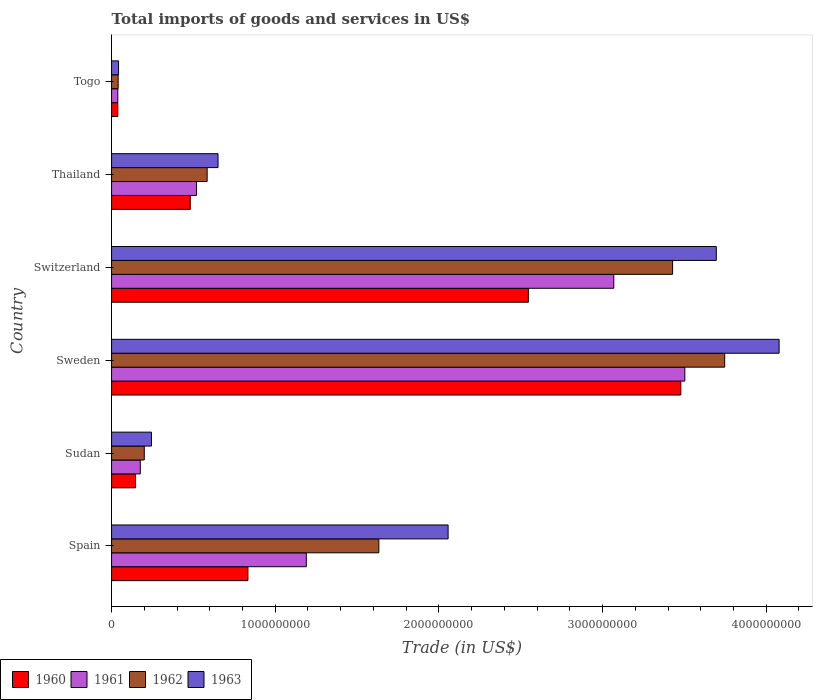How many groups of bars are there?
Your response must be concise. 6. Are the number of bars per tick equal to the number of legend labels?
Offer a terse response. Yes. Are the number of bars on each tick of the Y-axis equal?
Make the answer very short. Yes. What is the label of the 6th group of bars from the top?
Provide a short and direct response. Spain. What is the total imports of goods and services in 1961 in Switzerland?
Offer a terse response. 3.07e+09. Across all countries, what is the maximum total imports of goods and services in 1961?
Your response must be concise. 3.50e+09. Across all countries, what is the minimum total imports of goods and services in 1960?
Your answer should be compact. 3.82e+07. In which country was the total imports of goods and services in 1962 minimum?
Offer a very short reply. Togo. What is the total total imports of goods and services in 1961 in the graph?
Provide a succinct answer. 8.49e+09. What is the difference between the total imports of goods and services in 1963 in Sudan and that in Switzerland?
Provide a succinct answer. -3.45e+09. What is the difference between the total imports of goods and services in 1963 in Sudan and the total imports of goods and services in 1961 in Sweden?
Offer a terse response. -3.26e+09. What is the average total imports of goods and services in 1961 per country?
Offer a very short reply. 1.42e+09. What is the difference between the total imports of goods and services in 1960 and total imports of goods and services in 1962 in Thailand?
Ensure brevity in your answer.  -1.03e+08. What is the ratio of the total imports of goods and services in 1961 in Spain to that in Togo?
Keep it short and to the point. 31.15. Is the total imports of goods and services in 1962 in Sweden less than that in Thailand?
Ensure brevity in your answer.  No. Is the difference between the total imports of goods and services in 1960 in Thailand and Togo greater than the difference between the total imports of goods and services in 1962 in Thailand and Togo?
Keep it short and to the point. No. What is the difference between the highest and the second highest total imports of goods and services in 1963?
Your answer should be very brief. 3.84e+08. What is the difference between the highest and the lowest total imports of goods and services in 1960?
Make the answer very short. 3.44e+09. In how many countries, is the total imports of goods and services in 1963 greater than the average total imports of goods and services in 1963 taken over all countries?
Your response must be concise. 3. Is it the case that in every country, the sum of the total imports of goods and services in 1963 and total imports of goods and services in 1961 is greater than the sum of total imports of goods and services in 1960 and total imports of goods and services in 1962?
Give a very brief answer. No. What does the 3rd bar from the top in Togo represents?
Provide a succinct answer. 1961. What does the 2nd bar from the bottom in Sudan represents?
Provide a succinct answer. 1961. Is it the case that in every country, the sum of the total imports of goods and services in 1963 and total imports of goods and services in 1961 is greater than the total imports of goods and services in 1962?
Ensure brevity in your answer.  Yes. How many bars are there?
Offer a terse response. 24. What is the difference between two consecutive major ticks on the X-axis?
Provide a short and direct response. 1.00e+09. Does the graph contain any zero values?
Keep it short and to the point. No. Where does the legend appear in the graph?
Provide a succinct answer. Bottom left. How many legend labels are there?
Your answer should be compact. 4. How are the legend labels stacked?
Offer a terse response. Horizontal. What is the title of the graph?
Your response must be concise. Total imports of goods and services in US$. Does "2003" appear as one of the legend labels in the graph?
Provide a succinct answer. No. What is the label or title of the X-axis?
Offer a terse response. Trade (in US$). What is the label or title of the Y-axis?
Provide a succinct answer. Country. What is the Trade (in US$) of 1960 in Spain?
Provide a short and direct response. 8.33e+08. What is the Trade (in US$) in 1961 in Spain?
Your response must be concise. 1.19e+09. What is the Trade (in US$) of 1962 in Spain?
Offer a very short reply. 1.63e+09. What is the Trade (in US$) in 1963 in Spain?
Provide a short and direct response. 2.06e+09. What is the Trade (in US$) in 1960 in Sudan?
Give a very brief answer. 1.46e+08. What is the Trade (in US$) in 1961 in Sudan?
Your response must be concise. 1.75e+08. What is the Trade (in US$) of 1962 in Sudan?
Provide a succinct answer. 2.00e+08. What is the Trade (in US$) in 1963 in Sudan?
Offer a very short reply. 2.44e+08. What is the Trade (in US$) in 1960 in Sweden?
Ensure brevity in your answer.  3.48e+09. What is the Trade (in US$) in 1961 in Sweden?
Provide a short and direct response. 3.50e+09. What is the Trade (in US$) of 1962 in Sweden?
Provide a short and direct response. 3.75e+09. What is the Trade (in US$) in 1963 in Sweden?
Make the answer very short. 4.08e+09. What is the Trade (in US$) of 1960 in Switzerland?
Offer a very short reply. 2.55e+09. What is the Trade (in US$) in 1961 in Switzerland?
Provide a succinct answer. 3.07e+09. What is the Trade (in US$) in 1962 in Switzerland?
Give a very brief answer. 3.43e+09. What is the Trade (in US$) of 1963 in Switzerland?
Offer a terse response. 3.69e+09. What is the Trade (in US$) in 1960 in Thailand?
Make the answer very short. 4.81e+08. What is the Trade (in US$) in 1961 in Thailand?
Provide a short and direct response. 5.19e+08. What is the Trade (in US$) of 1962 in Thailand?
Ensure brevity in your answer.  5.84e+08. What is the Trade (in US$) of 1963 in Thailand?
Offer a very short reply. 6.51e+08. What is the Trade (in US$) of 1960 in Togo?
Give a very brief answer. 3.82e+07. What is the Trade (in US$) of 1961 in Togo?
Provide a short and direct response. 3.82e+07. What is the Trade (in US$) in 1962 in Togo?
Provide a succinct answer. 4.02e+07. What is the Trade (in US$) in 1963 in Togo?
Your answer should be very brief. 4.27e+07. Across all countries, what is the maximum Trade (in US$) of 1960?
Offer a terse response. 3.48e+09. Across all countries, what is the maximum Trade (in US$) of 1961?
Provide a short and direct response. 3.50e+09. Across all countries, what is the maximum Trade (in US$) of 1962?
Keep it short and to the point. 3.75e+09. Across all countries, what is the maximum Trade (in US$) in 1963?
Offer a terse response. 4.08e+09. Across all countries, what is the minimum Trade (in US$) in 1960?
Keep it short and to the point. 3.82e+07. Across all countries, what is the minimum Trade (in US$) in 1961?
Make the answer very short. 3.82e+07. Across all countries, what is the minimum Trade (in US$) of 1962?
Give a very brief answer. 4.02e+07. Across all countries, what is the minimum Trade (in US$) of 1963?
Offer a very short reply. 4.27e+07. What is the total Trade (in US$) in 1960 in the graph?
Give a very brief answer. 7.52e+09. What is the total Trade (in US$) of 1961 in the graph?
Give a very brief answer. 8.49e+09. What is the total Trade (in US$) in 1962 in the graph?
Offer a very short reply. 9.63e+09. What is the total Trade (in US$) in 1963 in the graph?
Provide a short and direct response. 1.08e+1. What is the difference between the Trade (in US$) in 1960 in Spain and that in Sudan?
Ensure brevity in your answer.  6.87e+08. What is the difference between the Trade (in US$) of 1961 in Spain and that in Sudan?
Your response must be concise. 1.01e+09. What is the difference between the Trade (in US$) in 1962 in Spain and that in Sudan?
Give a very brief answer. 1.43e+09. What is the difference between the Trade (in US$) in 1963 in Spain and that in Sudan?
Offer a very short reply. 1.81e+09. What is the difference between the Trade (in US$) of 1960 in Spain and that in Sweden?
Provide a succinct answer. -2.65e+09. What is the difference between the Trade (in US$) of 1961 in Spain and that in Sweden?
Your answer should be very brief. -2.31e+09. What is the difference between the Trade (in US$) in 1962 in Spain and that in Sweden?
Your response must be concise. -2.11e+09. What is the difference between the Trade (in US$) of 1963 in Spain and that in Sweden?
Offer a terse response. -2.02e+09. What is the difference between the Trade (in US$) of 1960 in Spain and that in Switzerland?
Keep it short and to the point. -1.71e+09. What is the difference between the Trade (in US$) of 1961 in Spain and that in Switzerland?
Your response must be concise. -1.88e+09. What is the difference between the Trade (in US$) of 1962 in Spain and that in Switzerland?
Your answer should be very brief. -1.79e+09. What is the difference between the Trade (in US$) in 1963 in Spain and that in Switzerland?
Keep it short and to the point. -1.64e+09. What is the difference between the Trade (in US$) of 1960 in Spain and that in Thailand?
Offer a very short reply. 3.52e+08. What is the difference between the Trade (in US$) of 1961 in Spain and that in Thailand?
Ensure brevity in your answer.  6.71e+08. What is the difference between the Trade (in US$) of 1962 in Spain and that in Thailand?
Keep it short and to the point. 1.05e+09. What is the difference between the Trade (in US$) of 1963 in Spain and that in Thailand?
Provide a succinct answer. 1.41e+09. What is the difference between the Trade (in US$) of 1960 in Spain and that in Togo?
Your response must be concise. 7.95e+08. What is the difference between the Trade (in US$) of 1961 in Spain and that in Togo?
Offer a very short reply. 1.15e+09. What is the difference between the Trade (in US$) of 1962 in Spain and that in Togo?
Offer a very short reply. 1.59e+09. What is the difference between the Trade (in US$) in 1963 in Spain and that in Togo?
Keep it short and to the point. 2.01e+09. What is the difference between the Trade (in US$) in 1960 in Sudan and that in Sweden?
Keep it short and to the point. -3.33e+09. What is the difference between the Trade (in US$) in 1961 in Sudan and that in Sweden?
Ensure brevity in your answer.  -3.33e+09. What is the difference between the Trade (in US$) in 1962 in Sudan and that in Sweden?
Offer a very short reply. -3.55e+09. What is the difference between the Trade (in US$) in 1963 in Sudan and that in Sweden?
Your answer should be very brief. -3.83e+09. What is the difference between the Trade (in US$) in 1960 in Sudan and that in Switzerland?
Your answer should be very brief. -2.40e+09. What is the difference between the Trade (in US$) of 1961 in Sudan and that in Switzerland?
Ensure brevity in your answer.  -2.89e+09. What is the difference between the Trade (in US$) in 1962 in Sudan and that in Switzerland?
Provide a short and direct response. -3.23e+09. What is the difference between the Trade (in US$) of 1963 in Sudan and that in Switzerland?
Your answer should be very brief. -3.45e+09. What is the difference between the Trade (in US$) of 1960 in Sudan and that in Thailand?
Ensure brevity in your answer.  -3.34e+08. What is the difference between the Trade (in US$) in 1961 in Sudan and that in Thailand?
Provide a short and direct response. -3.44e+08. What is the difference between the Trade (in US$) in 1962 in Sudan and that in Thailand?
Make the answer very short. -3.84e+08. What is the difference between the Trade (in US$) in 1963 in Sudan and that in Thailand?
Ensure brevity in your answer.  -4.07e+08. What is the difference between the Trade (in US$) of 1960 in Sudan and that in Togo?
Provide a short and direct response. 1.08e+08. What is the difference between the Trade (in US$) of 1961 in Sudan and that in Togo?
Provide a succinct answer. 1.37e+08. What is the difference between the Trade (in US$) in 1962 in Sudan and that in Togo?
Keep it short and to the point. 1.60e+08. What is the difference between the Trade (in US$) of 1963 in Sudan and that in Togo?
Your answer should be very brief. 2.01e+08. What is the difference between the Trade (in US$) in 1960 in Sweden and that in Switzerland?
Provide a succinct answer. 9.31e+08. What is the difference between the Trade (in US$) in 1961 in Sweden and that in Switzerland?
Your answer should be compact. 4.34e+08. What is the difference between the Trade (in US$) in 1962 in Sweden and that in Switzerland?
Your response must be concise. 3.18e+08. What is the difference between the Trade (in US$) of 1963 in Sweden and that in Switzerland?
Your answer should be compact. 3.84e+08. What is the difference between the Trade (in US$) in 1960 in Sweden and that in Thailand?
Give a very brief answer. 3.00e+09. What is the difference between the Trade (in US$) of 1961 in Sweden and that in Thailand?
Offer a very short reply. 2.98e+09. What is the difference between the Trade (in US$) of 1962 in Sweden and that in Thailand?
Your answer should be very brief. 3.16e+09. What is the difference between the Trade (in US$) of 1963 in Sweden and that in Thailand?
Give a very brief answer. 3.43e+09. What is the difference between the Trade (in US$) of 1960 in Sweden and that in Togo?
Make the answer very short. 3.44e+09. What is the difference between the Trade (in US$) in 1961 in Sweden and that in Togo?
Offer a terse response. 3.46e+09. What is the difference between the Trade (in US$) of 1962 in Sweden and that in Togo?
Your response must be concise. 3.71e+09. What is the difference between the Trade (in US$) of 1963 in Sweden and that in Togo?
Offer a very short reply. 4.04e+09. What is the difference between the Trade (in US$) of 1960 in Switzerland and that in Thailand?
Provide a short and direct response. 2.07e+09. What is the difference between the Trade (in US$) in 1961 in Switzerland and that in Thailand?
Offer a terse response. 2.55e+09. What is the difference between the Trade (in US$) in 1962 in Switzerland and that in Thailand?
Offer a very short reply. 2.84e+09. What is the difference between the Trade (in US$) in 1963 in Switzerland and that in Thailand?
Keep it short and to the point. 3.04e+09. What is the difference between the Trade (in US$) in 1960 in Switzerland and that in Togo?
Your answer should be compact. 2.51e+09. What is the difference between the Trade (in US$) in 1961 in Switzerland and that in Togo?
Make the answer very short. 3.03e+09. What is the difference between the Trade (in US$) of 1962 in Switzerland and that in Togo?
Make the answer very short. 3.39e+09. What is the difference between the Trade (in US$) of 1963 in Switzerland and that in Togo?
Your response must be concise. 3.65e+09. What is the difference between the Trade (in US$) in 1960 in Thailand and that in Togo?
Make the answer very short. 4.43e+08. What is the difference between the Trade (in US$) in 1961 in Thailand and that in Togo?
Offer a very short reply. 4.81e+08. What is the difference between the Trade (in US$) of 1962 in Thailand and that in Togo?
Your answer should be compact. 5.44e+08. What is the difference between the Trade (in US$) in 1963 in Thailand and that in Togo?
Ensure brevity in your answer.  6.08e+08. What is the difference between the Trade (in US$) of 1960 in Spain and the Trade (in US$) of 1961 in Sudan?
Offer a very short reply. 6.58e+08. What is the difference between the Trade (in US$) in 1960 in Spain and the Trade (in US$) in 1962 in Sudan?
Your response must be concise. 6.33e+08. What is the difference between the Trade (in US$) in 1960 in Spain and the Trade (in US$) in 1963 in Sudan?
Give a very brief answer. 5.89e+08. What is the difference between the Trade (in US$) of 1961 in Spain and the Trade (in US$) of 1962 in Sudan?
Offer a terse response. 9.90e+08. What is the difference between the Trade (in US$) of 1961 in Spain and the Trade (in US$) of 1963 in Sudan?
Your answer should be very brief. 9.46e+08. What is the difference between the Trade (in US$) of 1962 in Spain and the Trade (in US$) of 1963 in Sudan?
Your response must be concise. 1.39e+09. What is the difference between the Trade (in US$) of 1960 in Spain and the Trade (in US$) of 1961 in Sweden?
Keep it short and to the point. -2.67e+09. What is the difference between the Trade (in US$) in 1960 in Spain and the Trade (in US$) in 1962 in Sweden?
Provide a short and direct response. -2.91e+09. What is the difference between the Trade (in US$) in 1960 in Spain and the Trade (in US$) in 1963 in Sweden?
Offer a terse response. -3.25e+09. What is the difference between the Trade (in US$) in 1961 in Spain and the Trade (in US$) in 1962 in Sweden?
Ensure brevity in your answer.  -2.56e+09. What is the difference between the Trade (in US$) of 1961 in Spain and the Trade (in US$) of 1963 in Sweden?
Ensure brevity in your answer.  -2.89e+09. What is the difference between the Trade (in US$) in 1962 in Spain and the Trade (in US$) in 1963 in Sweden?
Your answer should be very brief. -2.45e+09. What is the difference between the Trade (in US$) of 1960 in Spain and the Trade (in US$) of 1961 in Switzerland?
Your response must be concise. -2.24e+09. What is the difference between the Trade (in US$) of 1960 in Spain and the Trade (in US$) of 1962 in Switzerland?
Your answer should be compact. -2.59e+09. What is the difference between the Trade (in US$) of 1960 in Spain and the Trade (in US$) of 1963 in Switzerland?
Your response must be concise. -2.86e+09. What is the difference between the Trade (in US$) of 1961 in Spain and the Trade (in US$) of 1962 in Switzerland?
Make the answer very short. -2.24e+09. What is the difference between the Trade (in US$) of 1961 in Spain and the Trade (in US$) of 1963 in Switzerland?
Keep it short and to the point. -2.50e+09. What is the difference between the Trade (in US$) in 1962 in Spain and the Trade (in US$) in 1963 in Switzerland?
Offer a very short reply. -2.06e+09. What is the difference between the Trade (in US$) of 1960 in Spain and the Trade (in US$) of 1961 in Thailand?
Your answer should be compact. 3.14e+08. What is the difference between the Trade (in US$) of 1960 in Spain and the Trade (in US$) of 1962 in Thailand?
Your answer should be very brief. 2.49e+08. What is the difference between the Trade (in US$) in 1960 in Spain and the Trade (in US$) in 1963 in Thailand?
Ensure brevity in your answer.  1.83e+08. What is the difference between the Trade (in US$) of 1961 in Spain and the Trade (in US$) of 1962 in Thailand?
Your response must be concise. 6.06e+08. What is the difference between the Trade (in US$) in 1961 in Spain and the Trade (in US$) in 1963 in Thailand?
Offer a terse response. 5.39e+08. What is the difference between the Trade (in US$) in 1962 in Spain and the Trade (in US$) in 1963 in Thailand?
Provide a succinct answer. 9.83e+08. What is the difference between the Trade (in US$) of 1960 in Spain and the Trade (in US$) of 1961 in Togo?
Provide a succinct answer. 7.95e+08. What is the difference between the Trade (in US$) in 1960 in Spain and the Trade (in US$) in 1962 in Togo?
Your answer should be very brief. 7.93e+08. What is the difference between the Trade (in US$) of 1960 in Spain and the Trade (in US$) of 1963 in Togo?
Your response must be concise. 7.90e+08. What is the difference between the Trade (in US$) of 1961 in Spain and the Trade (in US$) of 1962 in Togo?
Ensure brevity in your answer.  1.15e+09. What is the difference between the Trade (in US$) in 1961 in Spain and the Trade (in US$) in 1963 in Togo?
Provide a short and direct response. 1.15e+09. What is the difference between the Trade (in US$) in 1962 in Spain and the Trade (in US$) in 1963 in Togo?
Provide a succinct answer. 1.59e+09. What is the difference between the Trade (in US$) of 1960 in Sudan and the Trade (in US$) of 1961 in Sweden?
Your answer should be compact. -3.36e+09. What is the difference between the Trade (in US$) in 1960 in Sudan and the Trade (in US$) in 1962 in Sweden?
Ensure brevity in your answer.  -3.60e+09. What is the difference between the Trade (in US$) in 1960 in Sudan and the Trade (in US$) in 1963 in Sweden?
Keep it short and to the point. -3.93e+09. What is the difference between the Trade (in US$) of 1961 in Sudan and the Trade (in US$) of 1962 in Sweden?
Keep it short and to the point. -3.57e+09. What is the difference between the Trade (in US$) of 1961 in Sudan and the Trade (in US$) of 1963 in Sweden?
Offer a terse response. -3.90e+09. What is the difference between the Trade (in US$) in 1962 in Sudan and the Trade (in US$) in 1963 in Sweden?
Make the answer very short. -3.88e+09. What is the difference between the Trade (in US$) of 1960 in Sudan and the Trade (in US$) of 1961 in Switzerland?
Make the answer very short. -2.92e+09. What is the difference between the Trade (in US$) of 1960 in Sudan and the Trade (in US$) of 1962 in Switzerland?
Ensure brevity in your answer.  -3.28e+09. What is the difference between the Trade (in US$) of 1960 in Sudan and the Trade (in US$) of 1963 in Switzerland?
Your response must be concise. -3.55e+09. What is the difference between the Trade (in US$) in 1961 in Sudan and the Trade (in US$) in 1962 in Switzerland?
Provide a succinct answer. -3.25e+09. What is the difference between the Trade (in US$) in 1961 in Sudan and the Trade (in US$) in 1963 in Switzerland?
Ensure brevity in your answer.  -3.52e+09. What is the difference between the Trade (in US$) of 1962 in Sudan and the Trade (in US$) of 1963 in Switzerland?
Provide a short and direct response. -3.49e+09. What is the difference between the Trade (in US$) in 1960 in Sudan and the Trade (in US$) in 1961 in Thailand?
Your response must be concise. -3.73e+08. What is the difference between the Trade (in US$) in 1960 in Sudan and the Trade (in US$) in 1962 in Thailand?
Offer a terse response. -4.38e+08. What is the difference between the Trade (in US$) of 1960 in Sudan and the Trade (in US$) of 1963 in Thailand?
Make the answer very short. -5.04e+08. What is the difference between the Trade (in US$) of 1961 in Sudan and the Trade (in US$) of 1962 in Thailand?
Offer a terse response. -4.09e+08. What is the difference between the Trade (in US$) of 1961 in Sudan and the Trade (in US$) of 1963 in Thailand?
Make the answer very short. -4.75e+08. What is the difference between the Trade (in US$) of 1962 in Sudan and the Trade (in US$) of 1963 in Thailand?
Provide a short and direct response. -4.51e+08. What is the difference between the Trade (in US$) in 1960 in Sudan and the Trade (in US$) in 1961 in Togo?
Your answer should be very brief. 1.08e+08. What is the difference between the Trade (in US$) of 1960 in Sudan and the Trade (in US$) of 1962 in Togo?
Offer a terse response. 1.06e+08. What is the difference between the Trade (in US$) of 1960 in Sudan and the Trade (in US$) of 1963 in Togo?
Your response must be concise. 1.04e+08. What is the difference between the Trade (in US$) in 1961 in Sudan and the Trade (in US$) in 1962 in Togo?
Your answer should be compact. 1.35e+08. What is the difference between the Trade (in US$) in 1961 in Sudan and the Trade (in US$) in 1963 in Togo?
Provide a succinct answer. 1.33e+08. What is the difference between the Trade (in US$) in 1962 in Sudan and the Trade (in US$) in 1963 in Togo?
Offer a very short reply. 1.57e+08. What is the difference between the Trade (in US$) of 1960 in Sweden and the Trade (in US$) of 1961 in Switzerland?
Make the answer very short. 4.10e+08. What is the difference between the Trade (in US$) in 1960 in Sweden and the Trade (in US$) in 1962 in Switzerland?
Offer a very short reply. 5.05e+07. What is the difference between the Trade (in US$) in 1960 in Sweden and the Trade (in US$) in 1963 in Switzerland?
Your answer should be compact. -2.17e+08. What is the difference between the Trade (in US$) of 1961 in Sweden and the Trade (in US$) of 1962 in Switzerland?
Provide a short and direct response. 7.48e+07. What is the difference between the Trade (in US$) of 1961 in Sweden and the Trade (in US$) of 1963 in Switzerland?
Give a very brief answer. -1.92e+08. What is the difference between the Trade (in US$) of 1962 in Sweden and the Trade (in US$) of 1963 in Switzerland?
Ensure brevity in your answer.  5.13e+07. What is the difference between the Trade (in US$) in 1960 in Sweden and the Trade (in US$) in 1961 in Thailand?
Offer a terse response. 2.96e+09. What is the difference between the Trade (in US$) of 1960 in Sweden and the Trade (in US$) of 1962 in Thailand?
Keep it short and to the point. 2.89e+09. What is the difference between the Trade (in US$) of 1960 in Sweden and the Trade (in US$) of 1963 in Thailand?
Make the answer very short. 2.83e+09. What is the difference between the Trade (in US$) in 1961 in Sweden and the Trade (in US$) in 1962 in Thailand?
Provide a succinct answer. 2.92e+09. What is the difference between the Trade (in US$) of 1961 in Sweden and the Trade (in US$) of 1963 in Thailand?
Offer a very short reply. 2.85e+09. What is the difference between the Trade (in US$) in 1962 in Sweden and the Trade (in US$) in 1963 in Thailand?
Your answer should be compact. 3.10e+09. What is the difference between the Trade (in US$) of 1960 in Sweden and the Trade (in US$) of 1961 in Togo?
Make the answer very short. 3.44e+09. What is the difference between the Trade (in US$) in 1960 in Sweden and the Trade (in US$) in 1962 in Togo?
Provide a short and direct response. 3.44e+09. What is the difference between the Trade (in US$) of 1960 in Sweden and the Trade (in US$) of 1963 in Togo?
Offer a terse response. 3.44e+09. What is the difference between the Trade (in US$) of 1961 in Sweden and the Trade (in US$) of 1962 in Togo?
Keep it short and to the point. 3.46e+09. What is the difference between the Trade (in US$) of 1961 in Sweden and the Trade (in US$) of 1963 in Togo?
Provide a short and direct response. 3.46e+09. What is the difference between the Trade (in US$) of 1962 in Sweden and the Trade (in US$) of 1963 in Togo?
Give a very brief answer. 3.70e+09. What is the difference between the Trade (in US$) of 1960 in Switzerland and the Trade (in US$) of 1961 in Thailand?
Ensure brevity in your answer.  2.03e+09. What is the difference between the Trade (in US$) in 1960 in Switzerland and the Trade (in US$) in 1962 in Thailand?
Provide a short and direct response. 1.96e+09. What is the difference between the Trade (in US$) of 1960 in Switzerland and the Trade (in US$) of 1963 in Thailand?
Your response must be concise. 1.90e+09. What is the difference between the Trade (in US$) in 1961 in Switzerland and the Trade (in US$) in 1962 in Thailand?
Offer a very short reply. 2.48e+09. What is the difference between the Trade (in US$) of 1961 in Switzerland and the Trade (in US$) of 1963 in Thailand?
Keep it short and to the point. 2.42e+09. What is the difference between the Trade (in US$) in 1962 in Switzerland and the Trade (in US$) in 1963 in Thailand?
Offer a very short reply. 2.78e+09. What is the difference between the Trade (in US$) in 1960 in Switzerland and the Trade (in US$) in 1961 in Togo?
Make the answer very short. 2.51e+09. What is the difference between the Trade (in US$) in 1960 in Switzerland and the Trade (in US$) in 1962 in Togo?
Provide a succinct answer. 2.51e+09. What is the difference between the Trade (in US$) in 1960 in Switzerland and the Trade (in US$) in 1963 in Togo?
Your answer should be very brief. 2.50e+09. What is the difference between the Trade (in US$) of 1961 in Switzerland and the Trade (in US$) of 1962 in Togo?
Your answer should be very brief. 3.03e+09. What is the difference between the Trade (in US$) of 1961 in Switzerland and the Trade (in US$) of 1963 in Togo?
Provide a succinct answer. 3.03e+09. What is the difference between the Trade (in US$) in 1962 in Switzerland and the Trade (in US$) in 1963 in Togo?
Give a very brief answer. 3.38e+09. What is the difference between the Trade (in US$) of 1960 in Thailand and the Trade (in US$) of 1961 in Togo?
Your answer should be compact. 4.43e+08. What is the difference between the Trade (in US$) in 1960 in Thailand and the Trade (in US$) in 1962 in Togo?
Your response must be concise. 4.41e+08. What is the difference between the Trade (in US$) of 1960 in Thailand and the Trade (in US$) of 1963 in Togo?
Your answer should be very brief. 4.38e+08. What is the difference between the Trade (in US$) of 1961 in Thailand and the Trade (in US$) of 1962 in Togo?
Keep it short and to the point. 4.79e+08. What is the difference between the Trade (in US$) of 1961 in Thailand and the Trade (in US$) of 1963 in Togo?
Make the answer very short. 4.76e+08. What is the difference between the Trade (in US$) in 1962 in Thailand and the Trade (in US$) in 1963 in Togo?
Your answer should be compact. 5.41e+08. What is the average Trade (in US$) in 1960 per country?
Make the answer very short. 1.25e+09. What is the average Trade (in US$) of 1961 per country?
Make the answer very short. 1.42e+09. What is the average Trade (in US$) of 1962 per country?
Ensure brevity in your answer.  1.61e+09. What is the average Trade (in US$) in 1963 per country?
Make the answer very short. 1.79e+09. What is the difference between the Trade (in US$) of 1960 and Trade (in US$) of 1961 in Spain?
Ensure brevity in your answer.  -3.57e+08. What is the difference between the Trade (in US$) in 1960 and Trade (in US$) in 1962 in Spain?
Your answer should be compact. -8.00e+08. What is the difference between the Trade (in US$) of 1960 and Trade (in US$) of 1963 in Spain?
Offer a very short reply. -1.22e+09. What is the difference between the Trade (in US$) of 1961 and Trade (in US$) of 1962 in Spain?
Make the answer very short. -4.43e+08. What is the difference between the Trade (in US$) of 1961 and Trade (in US$) of 1963 in Spain?
Offer a terse response. -8.66e+08. What is the difference between the Trade (in US$) in 1962 and Trade (in US$) in 1963 in Spain?
Keep it short and to the point. -4.23e+08. What is the difference between the Trade (in US$) in 1960 and Trade (in US$) in 1961 in Sudan?
Give a very brief answer. -2.90e+07. What is the difference between the Trade (in US$) of 1960 and Trade (in US$) of 1962 in Sudan?
Your answer should be very brief. -5.34e+07. What is the difference between the Trade (in US$) of 1960 and Trade (in US$) of 1963 in Sudan?
Offer a terse response. -9.74e+07. What is the difference between the Trade (in US$) in 1961 and Trade (in US$) in 1962 in Sudan?
Give a very brief answer. -2.44e+07. What is the difference between the Trade (in US$) of 1961 and Trade (in US$) of 1963 in Sudan?
Give a very brief answer. -6.84e+07. What is the difference between the Trade (in US$) of 1962 and Trade (in US$) of 1963 in Sudan?
Offer a terse response. -4.39e+07. What is the difference between the Trade (in US$) of 1960 and Trade (in US$) of 1961 in Sweden?
Your answer should be compact. -2.44e+07. What is the difference between the Trade (in US$) of 1960 and Trade (in US$) of 1962 in Sweden?
Offer a very short reply. -2.68e+08. What is the difference between the Trade (in US$) in 1960 and Trade (in US$) in 1963 in Sweden?
Your response must be concise. -6.00e+08. What is the difference between the Trade (in US$) in 1961 and Trade (in US$) in 1962 in Sweden?
Offer a terse response. -2.44e+08. What is the difference between the Trade (in US$) of 1961 and Trade (in US$) of 1963 in Sweden?
Offer a very short reply. -5.76e+08. What is the difference between the Trade (in US$) in 1962 and Trade (in US$) in 1963 in Sweden?
Offer a terse response. -3.33e+08. What is the difference between the Trade (in US$) in 1960 and Trade (in US$) in 1961 in Switzerland?
Your answer should be very brief. -5.22e+08. What is the difference between the Trade (in US$) of 1960 and Trade (in US$) of 1962 in Switzerland?
Your response must be concise. -8.81e+08. What is the difference between the Trade (in US$) in 1960 and Trade (in US$) in 1963 in Switzerland?
Your answer should be very brief. -1.15e+09. What is the difference between the Trade (in US$) of 1961 and Trade (in US$) of 1962 in Switzerland?
Keep it short and to the point. -3.59e+08. What is the difference between the Trade (in US$) in 1961 and Trade (in US$) in 1963 in Switzerland?
Offer a terse response. -6.26e+08. What is the difference between the Trade (in US$) of 1962 and Trade (in US$) of 1963 in Switzerland?
Keep it short and to the point. -2.67e+08. What is the difference between the Trade (in US$) in 1960 and Trade (in US$) in 1961 in Thailand?
Provide a short and direct response. -3.83e+07. What is the difference between the Trade (in US$) of 1960 and Trade (in US$) of 1962 in Thailand?
Keep it short and to the point. -1.03e+08. What is the difference between the Trade (in US$) of 1960 and Trade (in US$) of 1963 in Thailand?
Your response must be concise. -1.70e+08. What is the difference between the Trade (in US$) in 1961 and Trade (in US$) in 1962 in Thailand?
Give a very brief answer. -6.49e+07. What is the difference between the Trade (in US$) of 1961 and Trade (in US$) of 1963 in Thailand?
Make the answer very short. -1.31e+08. What is the difference between the Trade (in US$) of 1962 and Trade (in US$) of 1963 in Thailand?
Make the answer very short. -6.65e+07. What is the difference between the Trade (in US$) of 1960 and Trade (in US$) of 1961 in Togo?
Your answer should be very brief. 1.01e+04. What is the difference between the Trade (in US$) in 1960 and Trade (in US$) in 1962 in Togo?
Give a very brief answer. -2.01e+06. What is the difference between the Trade (in US$) in 1960 and Trade (in US$) in 1963 in Togo?
Give a very brief answer. -4.50e+06. What is the difference between the Trade (in US$) in 1961 and Trade (in US$) in 1962 in Togo?
Your response must be concise. -2.03e+06. What is the difference between the Trade (in US$) in 1961 and Trade (in US$) in 1963 in Togo?
Your response must be concise. -4.51e+06. What is the difference between the Trade (in US$) of 1962 and Trade (in US$) of 1963 in Togo?
Give a very brief answer. -2.48e+06. What is the ratio of the Trade (in US$) in 1960 in Spain to that in Sudan?
Your answer should be compact. 5.69. What is the ratio of the Trade (in US$) of 1961 in Spain to that in Sudan?
Make the answer very short. 6.78. What is the ratio of the Trade (in US$) in 1962 in Spain to that in Sudan?
Your answer should be compact. 8.17. What is the ratio of the Trade (in US$) in 1963 in Spain to that in Sudan?
Your answer should be very brief. 8.43. What is the ratio of the Trade (in US$) in 1960 in Spain to that in Sweden?
Provide a short and direct response. 0.24. What is the ratio of the Trade (in US$) in 1961 in Spain to that in Sweden?
Offer a very short reply. 0.34. What is the ratio of the Trade (in US$) of 1962 in Spain to that in Sweden?
Make the answer very short. 0.44. What is the ratio of the Trade (in US$) of 1963 in Spain to that in Sweden?
Your answer should be compact. 0.5. What is the ratio of the Trade (in US$) of 1960 in Spain to that in Switzerland?
Ensure brevity in your answer.  0.33. What is the ratio of the Trade (in US$) of 1961 in Spain to that in Switzerland?
Keep it short and to the point. 0.39. What is the ratio of the Trade (in US$) in 1962 in Spain to that in Switzerland?
Your response must be concise. 0.48. What is the ratio of the Trade (in US$) of 1963 in Spain to that in Switzerland?
Your response must be concise. 0.56. What is the ratio of the Trade (in US$) in 1960 in Spain to that in Thailand?
Offer a very short reply. 1.73. What is the ratio of the Trade (in US$) in 1961 in Spain to that in Thailand?
Your answer should be compact. 2.29. What is the ratio of the Trade (in US$) in 1962 in Spain to that in Thailand?
Provide a short and direct response. 2.8. What is the ratio of the Trade (in US$) of 1963 in Spain to that in Thailand?
Make the answer very short. 3.16. What is the ratio of the Trade (in US$) of 1960 in Spain to that in Togo?
Your answer should be compact. 21.8. What is the ratio of the Trade (in US$) of 1961 in Spain to that in Togo?
Provide a short and direct response. 31.15. What is the ratio of the Trade (in US$) in 1962 in Spain to that in Togo?
Give a very brief answer. 40.59. What is the ratio of the Trade (in US$) of 1963 in Spain to that in Togo?
Offer a terse response. 48.14. What is the ratio of the Trade (in US$) in 1960 in Sudan to that in Sweden?
Your answer should be compact. 0.04. What is the ratio of the Trade (in US$) of 1961 in Sudan to that in Sweden?
Keep it short and to the point. 0.05. What is the ratio of the Trade (in US$) of 1962 in Sudan to that in Sweden?
Offer a terse response. 0.05. What is the ratio of the Trade (in US$) in 1963 in Sudan to that in Sweden?
Ensure brevity in your answer.  0.06. What is the ratio of the Trade (in US$) in 1960 in Sudan to that in Switzerland?
Your answer should be compact. 0.06. What is the ratio of the Trade (in US$) in 1961 in Sudan to that in Switzerland?
Ensure brevity in your answer.  0.06. What is the ratio of the Trade (in US$) in 1962 in Sudan to that in Switzerland?
Your response must be concise. 0.06. What is the ratio of the Trade (in US$) in 1963 in Sudan to that in Switzerland?
Ensure brevity in your answer.  0.07. What is the ratio of the Trade (in US$) in 1960 in Sudan to that in Thailand?
Make the answer very short. 0.3. What is the ratio of the Trade (in US$) in 1961 in Sudan to that in Thailand?
Ensure brevity in your answer.  0.34. What is the ratio of the Trade (in US$) of 1962 in Sudan to that in Thailand?
Provide a short and direct response. 0.34. What is the ratio of the Trade (in US$) in 1963 in Sudan to that in Thailand?
Keep it short and to the point. 0.37. What is the ratio of the Trade (in US$) of 1960 in Sudan to that in Togo?
Give a very brief answer. 3.83. What is the ratio of the Trade (in US$) in 1961 in Sudan to that in Togo?
Provide a short and direct response. 4.59. What is the ratio of the Trade (in US$) of 1962 in Sudan to that in Togo?
Give a very brief answer. 4.97. What is the ratio of the Trade (in US$) of 1963 in Sudan to that in Togo?
Ensure brevity in your answer.  5.71. What is the ratio of the Trade (in US$) in 1960 in Sweden to that in Switzerland?
Offer a very short reply. 1.37. What is the ratio of the Trade (in US$) in 1961 in Sweden to that in Switzerland?
Your answer should be very brief. 1.14. What is the ratio of the Trade (in US$) in 1962 in Sweden to that in Switzerland?
Provide a short and direct response. 1.09. What is the ratio of the Trade (in US$) of 1963 in Sweden to that in Switzerland?
Provide a succinct answer. 1.1. What is the ratio of the Trade (in US$) of 1960 in Sweden to that in Thailand?
Your response must be concise. 7.23. What is the ratio of the Trade (in US$) of 1961 in Sweden to that in Thailand?
Provide a succinct answer. 6.75. What is the ratio of the Trade (in US$) of 1962 in Sweden to that in Thailand?
Your response must be concise. 6.41. What is the ratio of the Trade (in US$) of 1963 in Sweden to that in Thailand?
Provide a succinct answer. 6.27. What is the ratio of the Trade (in US$) in 1960 in Sweden to that in Togo?
Keep it short and to the point. 91.02. What is the ratio of the Trade (in US$) in 1961 in Sweden to that in Togo?
Your answer should be very brief. 91.68. What is the ratio of the Trade (in US$) in 1962 in Sweden to that in Togo?
Your response must be concise. 93.12. What is the ratio of the Trade (in US$) in 1963 in Sweden to that in Togo?
Your answer should be very brief. 95.49. What is the ratio of the Trade (in US$) in 1960 in Switzerland to that in Thailand?
Offer a very short reply. 5.3. What is the ratio of the Trade (in US$) of 1961 in Switzerland to that in Thailand?
Make the answer very short. 5.91. What is the ratio of the Trade (in US$) in 1962 in Switzerland to that in Thailand?
Offer a very short reply. 5.87. What is the ratio of the Trade (in US$) in 1963 in Switzerland to that in Thailand?
Give a very brief answer. 5.68. What is the ratio of the Trade (in US$) of 1960 in Switzerland to that in Togo?
Offer a terse response. 66.65. What is the ratio of the Trade (in US$) in 1961 in Switzerland to that in Togo?
Give a very brief answer. 80.32. What is the ratio of the Trade (in US$) of 1962 in Switzerland to that in Togo?
Your answer should be very brief. 85.2. What is the ratio of the Trade (in US$) in 1963 in Switzerland to that in Togo?
Offer a terse response. 86.5. What is the ratio of the Trade (in US$) in 1960 in Thailand to that in Togo?
Your answer should be very brief. 12.58. What is the ratio of the Trade (in US$) of 1961 in Thailand to that in Togo?
Offer a very short reply. 13.59. What is the ratio of the Trade (in US$) of 1962 in Thailand to that in Togo?
Make the answer very short. 14.52. What is the ratio of the Trade (in US$) of 1963 in Thailand to that in Togo?
Give a very brief answer. 15.23. What is the difference between the highest and the second highest Trade (in US$) of 1960?
Keep it short and to the point. 9.31e+08. What is the difference between the highest and the second highest Trade (in US$) of 1961?
Provide a succinct answer. 4.34e+08. What is the difference between the highest and the second highest Trade (in US$) of 1962?
Keep it short and to the point. 3.18e+08. What is the difference between the highest and the second highest Trade (in US$) in 1963?
Provide a succinct answer. 3.84e+08. What is the difference between the highest and the lowest Trade (in US$) of 1960?
Your answer should be compact. 3.44e+09. What is the difference between the highest and the lowest Trade (in US$) of 1961?
Your answer should be very brief. 3.46e+09. What is the difference between the highest and the lowest Trade (in US$) in 1962?
Ensure brevity in your answer.  3.71e+09. What is the difference between the highest and the lowest Trade (in US$) in 1963?
Ensure brevity in your answer.  4.04e+09. 